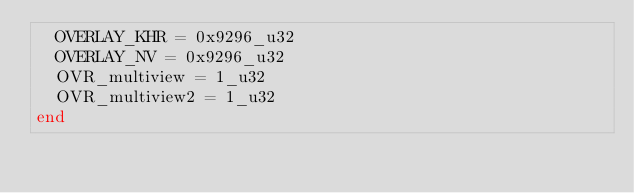<code> <loc_0><loc_0><loc_500><loc_500><_Crystal_>  OVERLAY_KHR = 0x9296_u32
  OVERLAY_NV = 0x9296_u32
  OVR_multiview = 1_u32
  OVR_multiview2 = 1_u32
end
</code> 